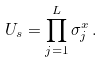<formula> <loc_0><loc_0><loc_500><loc_500>U _ { s } = \prod _ { j = 1 } ^ { L } \sigma _ { j } ^ { x } \, .</formula> 